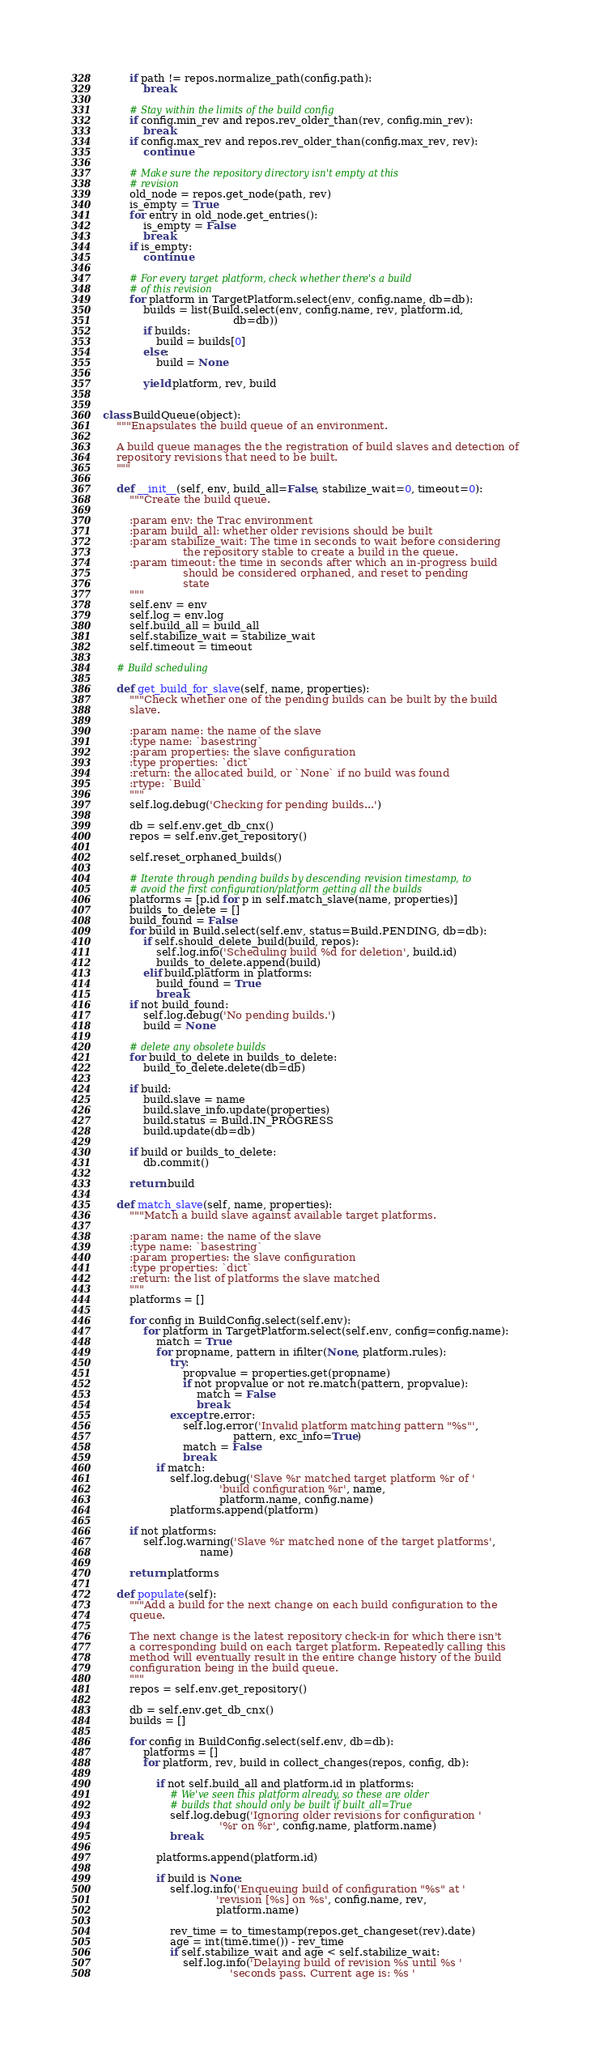<code> <loc_0><loc_0><loc_500><loc_500><_Python_>        if path != repos.normalize_path(config.path):
            break

        # Stay within the limits of the build config
        if config.min_rev and repos.rev_older_than(rev, config.min_rev):
            break
        if config.max_rev and repos.rev_older_than(config.max_rev, rev):
            continue

        # Make sure the repository directory isn't empty at this
        # revision
        old_node = repos.get_node(path, rev)
        is_empty = True
        for entry in old_node.get_entries():
            is_empty = False
            break
        if is_empty:
            continue

        # For every target platform, check whether there's a build
        # of this revision
        for platform in TargetPlatform.select(env, config.name, db=db):
            builds = list(Build.select(env, config.name, rev, platform.id,
                                       db=db))
            if builds:
                build = builds[0]
            else:
                build = None

            yield platform, rev, build


class BuildQueue(object):
    """Enapsulates the build queue of an environment.
    
    A build queue manages the the registration of build slaves and detection of
    repository revisions that need to be built.
    """

    def __init__(self, env, build_all=False, stabilize_wait=0, timeout=0):
        """Create the build queue.
        
        :param env: the Trac environment
        :param build_all: whether older revisions should be built
        :param stabilize_wait: The time in seconds to wait before considering
                        the repository stable to create a build in the queue.
        :param timeout: the time in seconds after which an in-progress build
                        should be considered orphaned, and reset to pending
                        state
        """
        self.env = env
        self.log = env.log
        self.build_all = build_all
        self.stabilize_wait = stabilize_wait
        self.timeout = timeout

    # Build scheduling

    def get_build_for_slave(self, name, properties):
        """Check whether one of the pending builds can be built by the build
        slave.
        
        :param name: the name of the slave
        :type name: `basestring`
        :param properties: the slave configuration
        :type properties: `dict`
        :return: the allocated build, or `None` if no build was found
        :rtype: `Build`
        """
        self.log.debug('Checking for pending builds...')

        db = self.env.get_db_cnx()
        repos = self.env.get_repository()

        self.reset_orphaned_builds()

        # Iterate through pending builds by descending revision timestamp, to
        # avoid the first configuration/platform getting all the builds
        platforms = [p.id for p in self.match_slave(name, properties)]
        builds_to_delete = []
        build_found = False
        for build in Build.select(self.env, status=Build.PENDING, db=db):
            if self.should_delete_build(build, repos):
                self.log.info('Scheduling build %d for deletion', build.id)
                builds_to_delete.append(build)
            elif build.platform in platforms:
                build_found = True
                break
        if not build_found:
            self.log.debug('No pending builds.')
            build = None

        # delete any obsolete builds
        for build_to_delete in builds_to_delete:
            build_to_delete.delete(db=db)

        if build:
            build.slave = name
            build.slave_info.update(properties)
            build.status = Build.IN_PROGRESS
            build.update(db=db)

        if build or builds_to_delete:
            db.commit()

        return build

    def match_slave(self, name, properties):
        """Match a build slave against available target platforms.
        
        :param name: the name of the slave
        :type name: `basestring`
        :param properties: the slave configuration
        :type properties: `dict`
        :return: the list of platforms the slave matched
        """
        platforms = []

        for config in BuildConfig.select(self.env):
            for platform in TargetPlatform.select(self.env, config=config.name):
                match = True
                for propname, pattern in ifilter(None, platform.rules):
                    try:
                        propvalue = properties.get(propname)
                        if not propvalue or not re.match(pattern, propvalue):
                            match = False
                            break
                    except re.error:
                        self.log.error('Invalid platform matching pattern "%s"',
                                       pattern, exc_info=True)
                        match = False
                        break
                if match:
                    self.log.debug('Slave %r matched target platform %r of '
                                   'build configuration %r', name,
                                   platform.name, config.name)
                    platforms.append(platform)

        if not platforms:
            self.log.warning('Slave %r matched none of the target platforms',
                             name)

        return platforms

    def populate(self):
        """Add a build for the next change on each build configuration to the
        queue.

        The next change is the latest repository check-in for which there isn't
        a corresponding build on each target platform. Repeatedly calling this
        method will eventually result in the entire change history of the build
        configuration being in the build queue.
        """
        repos = self.env.get_repository()

        db = self.env.get_db_cnx()
        builds = []

        for config in BuildConfig.select(self.env, db=db):
            platforms = []
            for platform, rev, build in collect_changes(repos, config, db):

                if not self.build_all and platform.id in platforms:
                    # We've seen this platform already, so these are older
                    # builds that should only be built if built_all=True
                    self.log.debug('Ignoring older revisions for configuration '
                                   '%r on %r', config.name, platform.name)
                    break

                platforms.append(platform.id)

                if build is None:
                    self.log.info('Enqueuing build of configuration "%s" at '
                                  'revision [%s] on %s', config.name, rev,
                                  platform.name)

                    rev_time = to_timestamp(repos.get_changeset(rev).date)
                    age = int(time.time()) - rev_time
                    if self.stabilize_wait and age < self.stabilize_wait:
                        self.log.info('Delaying build of revision %s until %s '
                                      'seconds pass. Current age is: %s '</code> 